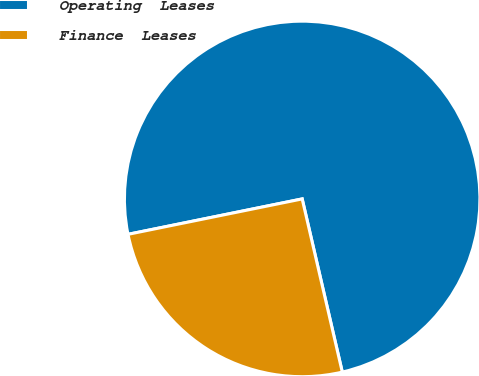<chart> <loc_0><loc_0><loc_500><loc_500><pie_chart><fcel>Operating  Leases<fcel>Finance  Leases<nl><fcel>74.57%<fcel>25.43%<nl></chart> 